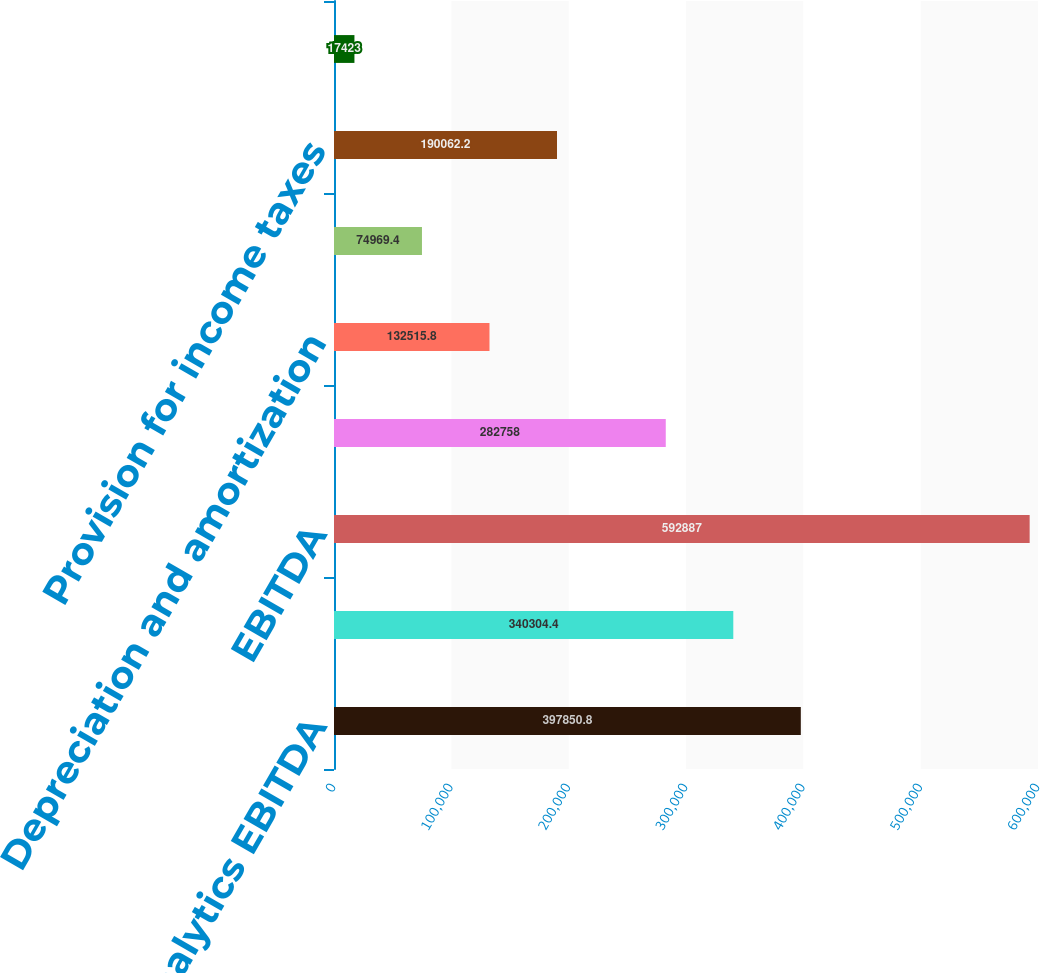<chart> <loc_0><loc_0><loc_500><loc_500><bar_chart><fcel>Decision Analytics EBITDA<fcel>Risk Assessment EBITDA<fcel>EBITDA<fcel>Net income<fcel>Depreciation and amortization<fcel>Interest expense from<fcel>Provision for income taxes<fcel>Depreciation amortization<nl><fcel>397851<fcel>340304<fcel>592887<fcel>282758<fcel>132516<fcel>74969.4<fcel>190062<fcel>17423<nl></chart> 